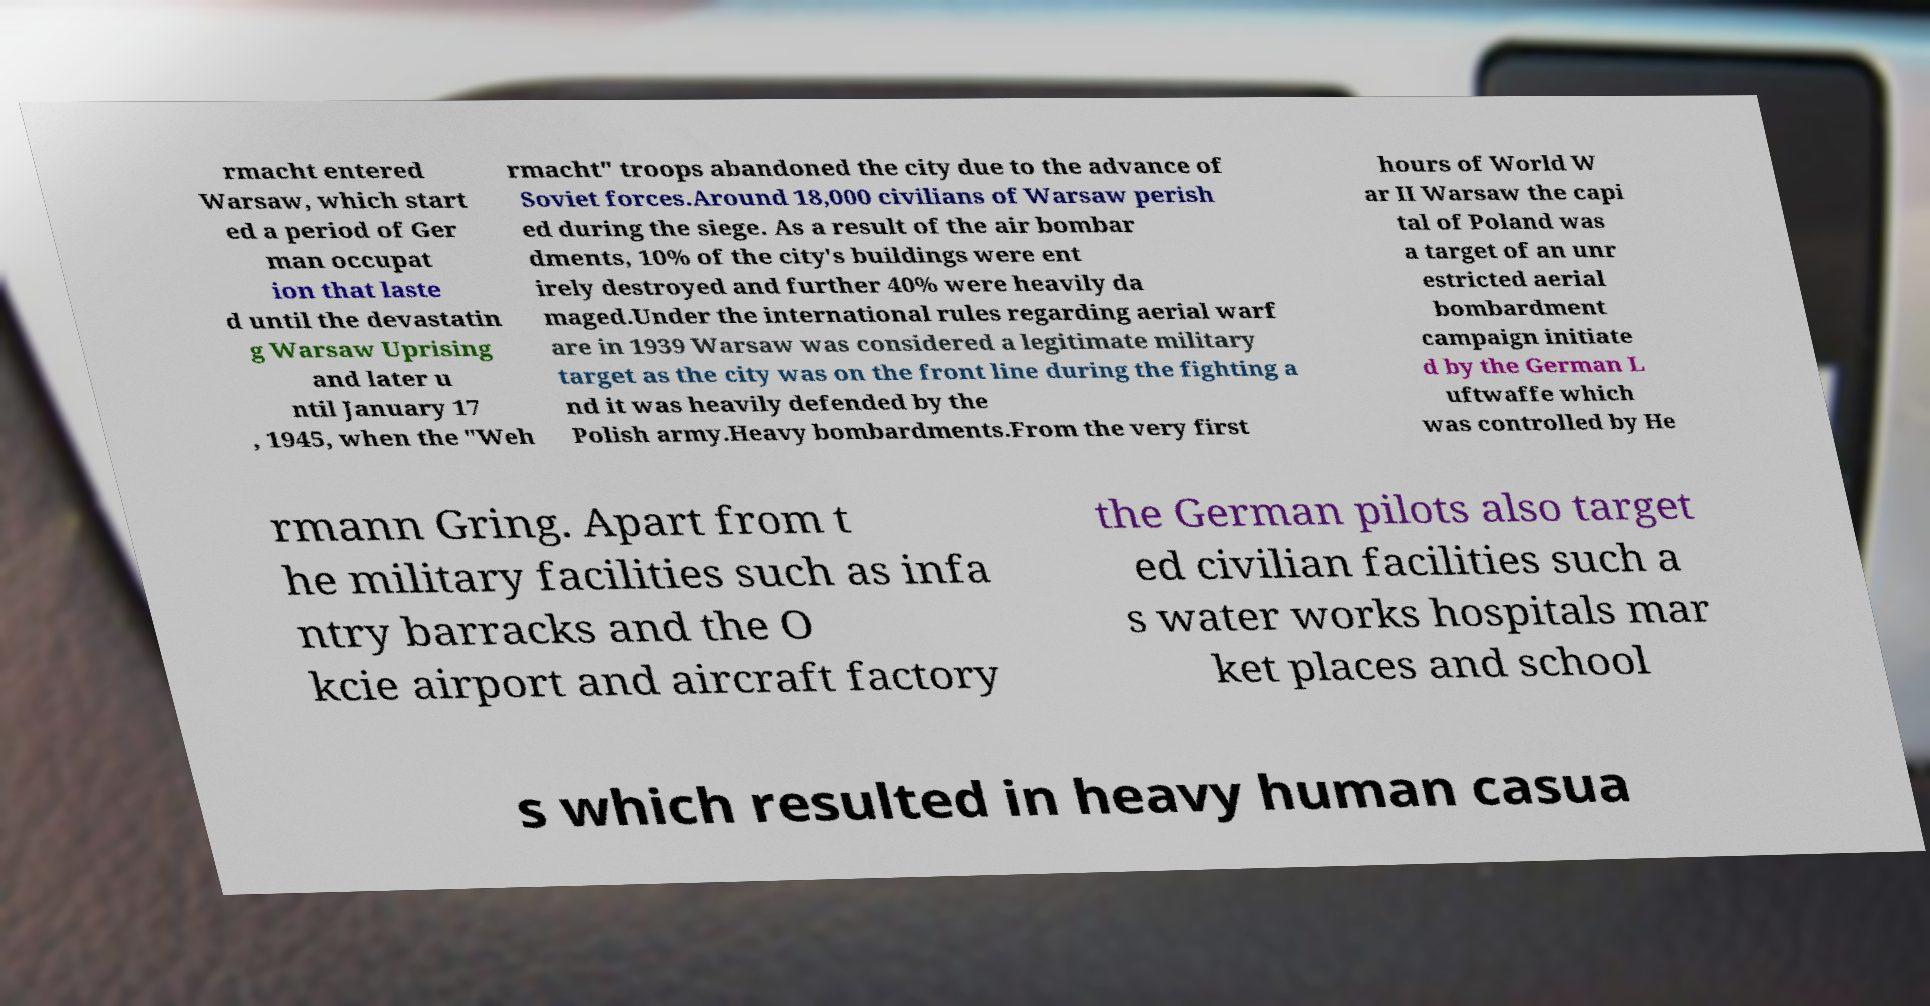Can you read and provide the text displayed in the image?This photo seems to have some interesting text. Can you extract and type it out for me? rmacht entered Warsaw, which start ed a period of Ger man occupat ion that laste d until the devastatin g Warsaw Uprising and later u ntil January 17 , 1945, when the "Weh rmacht" troops abandoned the city due to the advance of Soviet forces.Around 18,000 civilians of Warsaw perish ed during the siege. As a result of the air bombar dments, 10% of the city's buildings were ent irely destroyed and further 40% were heavily da maged.Under the international rules regarding aerial warf are in 1939 Warsaw was considered a legitimate military target as the city was on the front line during the fighting a nd it was heavily defended by the Polish army.Heavy bombardments.From the very first hours of World W ar II Warsaw the capi tal of Poland was a target of an unr estricted aerial bombardment campaign initiate d by the German L uftwaffe which was controlled by He rmann Gring. Apart from t he military facilities such as infa ntry barracks and the O kcie airport and aircraft factory the German pilots also target ed civilian facilities such a s water works hospitals mar ket places and school s which resulted in heavy human casua 